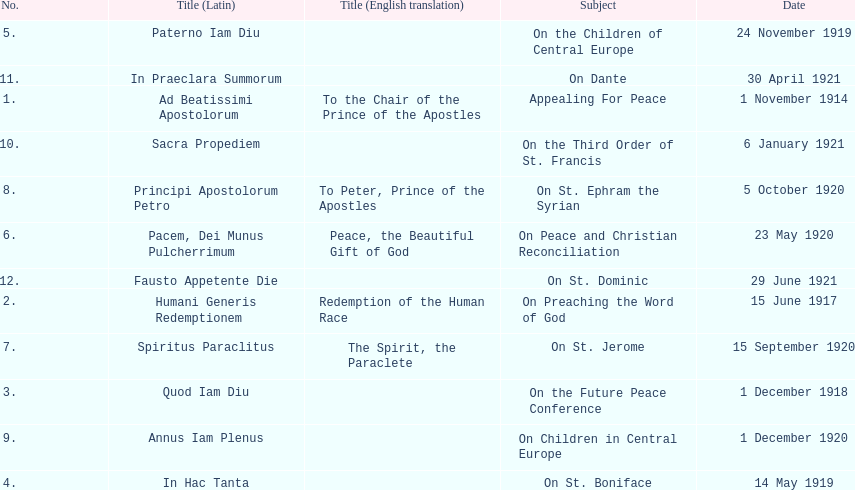Write the full table. {'header': ['No.', 'Title (Latin)', 'Title (English translation)', 'Subject', 'Date'], 'rows': [['5.', 'Paterno Iam Diu', '', 'On the Children of Central Europe', '24 November 1919'], ['11.', 'In Praeclara Summorum', '', 'On Dante', '30 April 1921'], ['1.', 'Ad Beatissimi Apostolorum', 'To the Chair of the Prince of the Apostles', 'Appealing For Peace', '1 November 1914'], ['10.', 'Sacra Propediem', '', 'On the Third Order of St. Francis', '6 January 1921'], ['8.', 'Principi Apostolorum Petro', 'To Peter, Prince of the Apostles', 'On St. Ephram the Syrian', '5 October 1920'], ['6.', 'Pacem, Dei Munus Pulcherrimum', 'Peace, the Beautiful Gift of God', 'On Peace and Christian Reconciliation', '23 May 1920'], ['12.', 'Fausto Appetente Die', '', 'On St. Dominic', '29 June 1921'], ['2.', 'Humani Generis Redemptionem', 'Redemption of the Human Race', 'On Preaching the Word of God', '15 June 1917'], ['7.', 'Spiritus Paraclitus', 'The Spirit, the Paraclete', 'On St. Jerome', '15 September 1920'], ['3.', 'Quod Iam Diu', '', 'On the Future Peace Conference', '1 December 1918'], ['9.', 'Annus Iam Plenus', '', 'On Children in Central Europe', '1 December 1920'], ['4.', 'In Hac Tanta', '', 'On St. Boniface', '14 May 1919']]} What is the title that follows sacra propediem in the list? In Praeclara Summorum. 